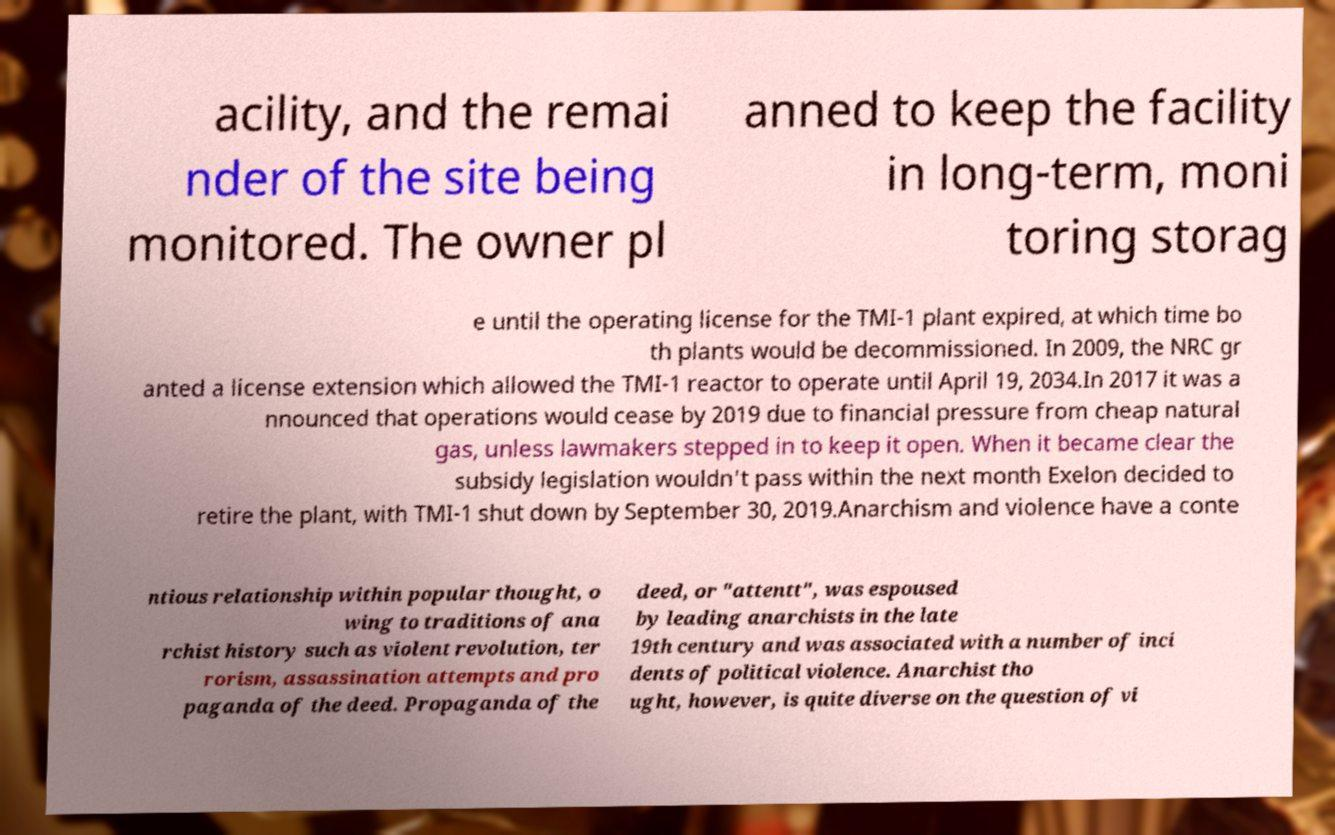Can you read and provide the text displayed in the image?This photo seems to have some interesting text. Can you extract and type it out for me? acility, and the remai nder of the site being monitored. The owner pl anned to keep the facility in long-term, moni toring storag e until the operating license for the TMI-1 plant expired, at which time bo th plants would be decommissioned. In 2009, the NRC gr anted a license extension which allowed the TMI-1 reactor to operate until April 19, 2034.In 2017 it was a nnounced that operations would cease by 2019 due to financial pressure from cheap natural gas, unless lawmakers stepped in to keep it open. When it became clear the subsidy legislation wouldn't pass within the next month Exelon decided to retire the plant, with TMI-1 shut down by September 30, 2019.Anarchism and violence have a conte ntious relationship within popular thought, o wing to traditions of ana rchist history such as violent revolution, ter rorism, assassination attempts and pro paganda of the deed. Propaganda of the deed, or "attentt", was espoused by leading anarchists in the late 19th century and was associated with a number of inci dents of political violence. Anarchist tho ught, however, is quite diverse on the question of vi 